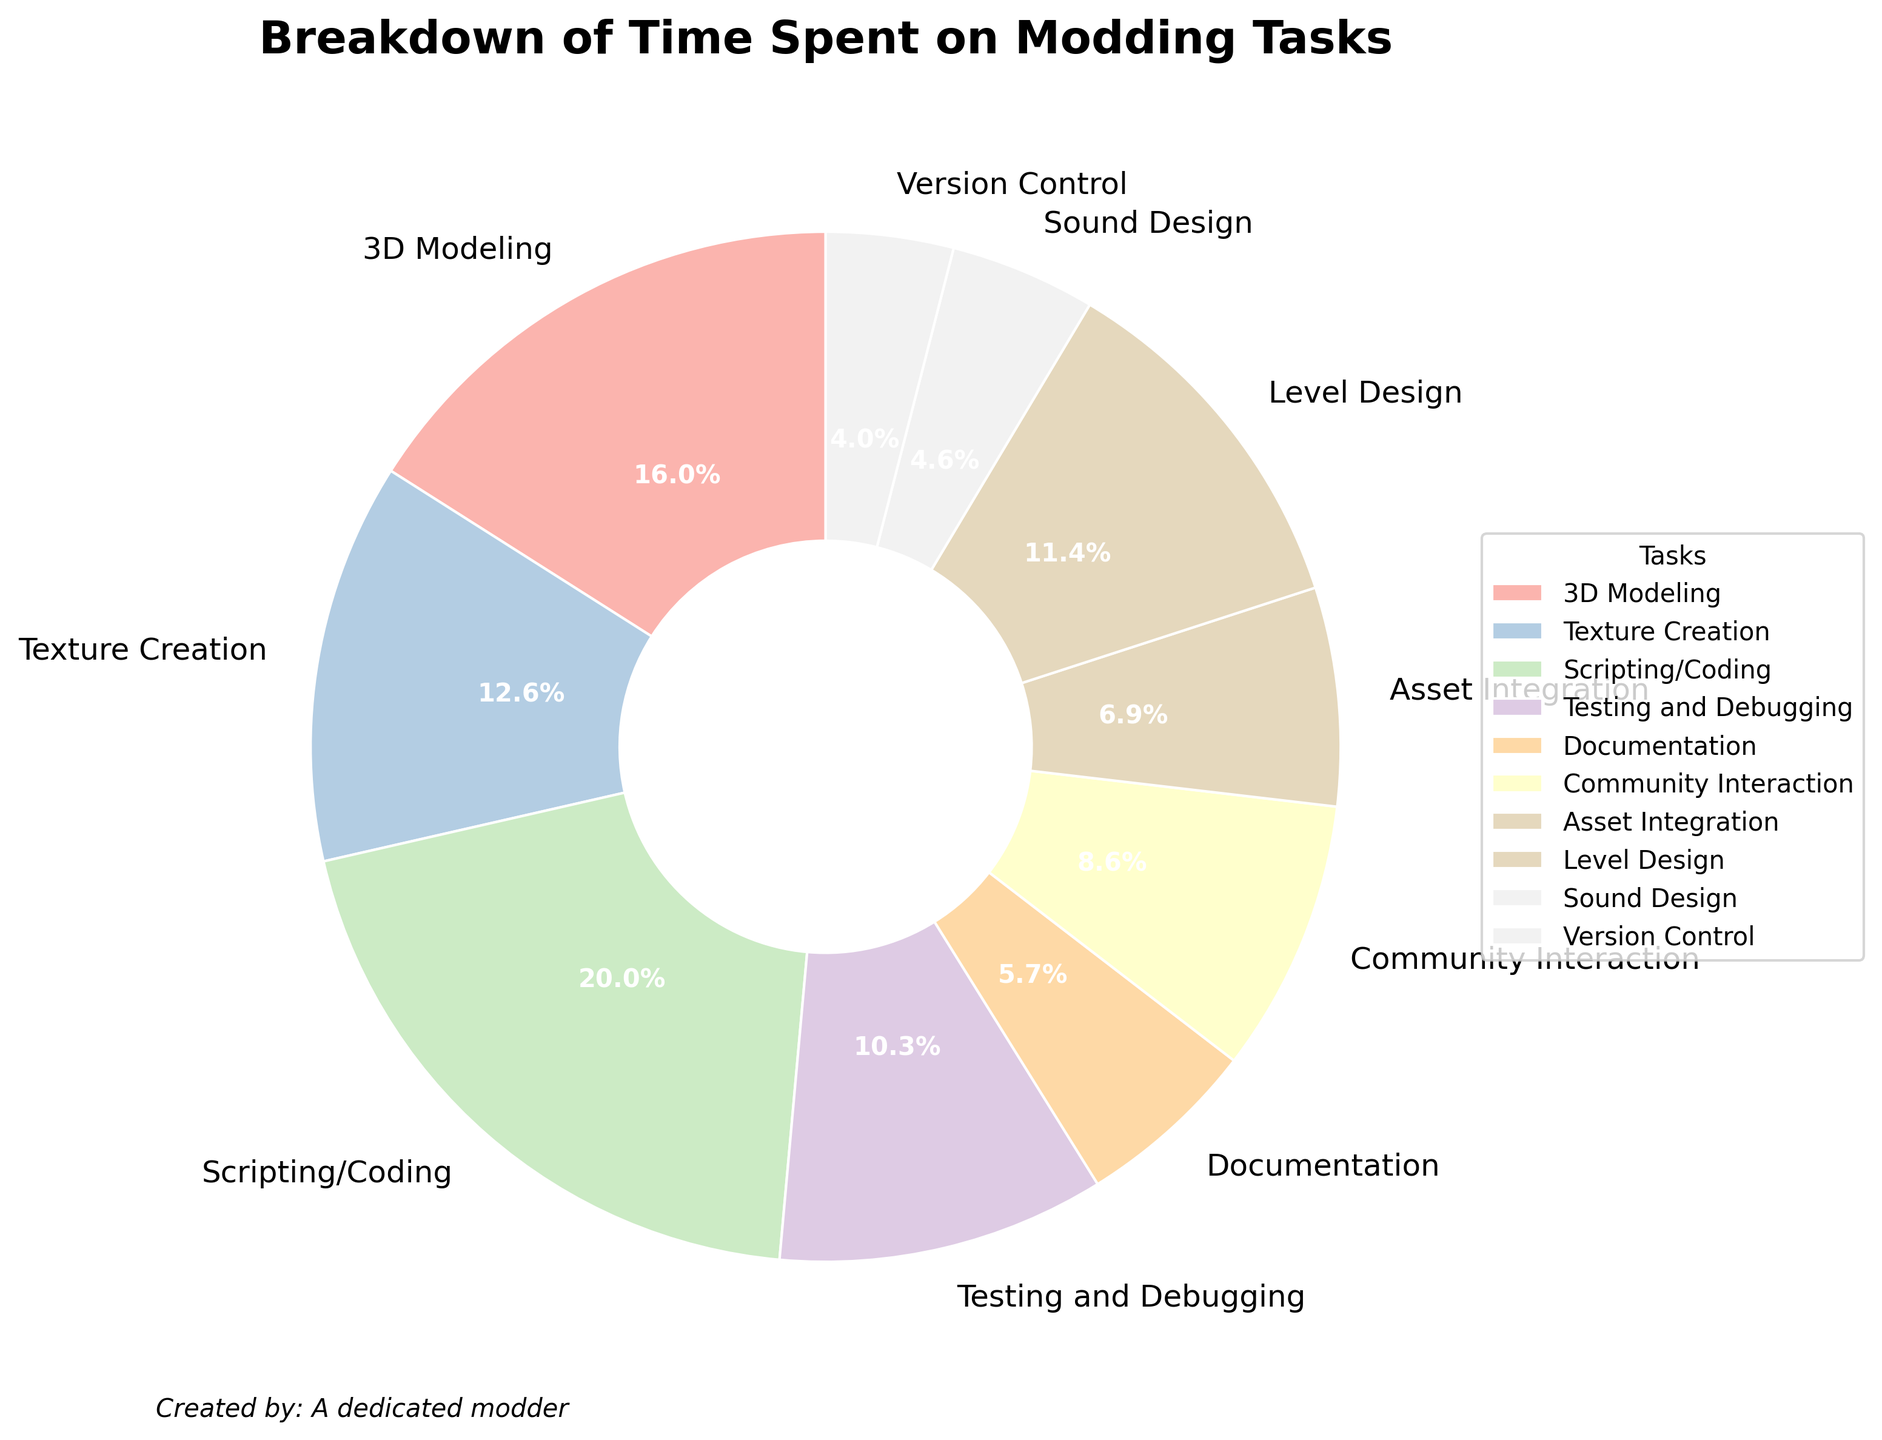What percentage of time is spent on Scripting/Coding? Scripting/Coding takes up one segment of the pie chart. The chart shows that 35 hours are spent on this task out of the total hours. To find the percentage, we use the value provided in the chart.
Answer: 35% Which modding task consumes the most time and what is its percentage? The largest wedge in the pie chart represents the modding task that consumes the most time. The chart shows that Scripting/Coding takes the biggest portion at 35%.
Answer: Scripting/Coding, 35% How much more time is spent on 3D Modeling compared to Sound Design? To find how much more time is spent on 3D Modeling compared to Sound Design, we subtract the hours spent on Sound Design from the hours spent on 3D Modeling: 28 hours - 8 hours = 20 hours.
Answer: 20 hours What two tasks have the closest amount of time spent on them? By examining the wedges of the pie chart, we look for two segments that have similar sizes. Texture Creation (22 hours) and Level Design (20 hours) are closest.
Answer: Texture Creation and Level Design What is the combined percentage of time spent on Texture Creation, Scripting/Coding, and Testing and Debugging? First, find the individual percentages from the chart: Texture Creation (22 hours), Scripting/Coding (35 hours), and Testing and Debugging (18 hours). Add these percentages: 22 + 35 + 18 = 75%.
Answer: 75% Does Community Interaction take up more time than Asset Integration? Compare the size of the wedges representing Community Interaction (15 hours) and Asset Integration (12 hours). Community Interaction is larger.
Answer: Yes Which task takes the least amount of time and what is its percentage? Identify the smallest wedge in the pie chart. Version Control represents the smallest segment with 7 hours. Find its percentage from the chart.
Answer: Version Control, 7% What is the sum of hours spent on Level Design, Asset Integration, and Sound Design? Add the hours for these tasks from the chart: Level Design (20 hours) + Asset Integration (12 hours) + Sound Design (8 hours) = 40 hours.
Answer: 40 hours Is the time spent on Testing and Debugging greater than the combined time spent on Community Interaction and Sound Design? First, add the hours for Community Interaction (15 hours) and Sound Design (8 hours): 15 + 8 = 23 hours. Then, compare with Testing and Debugging (18 hours). 18 < 23, hence, no.
Answer: No What is the percentage share of the task with the second highest time spent? The task with the second highest time spent appears to be 3D Modeling, which has 28 hours. Find its percentage from the chart.
Answer: 3D Modeling, 28% 